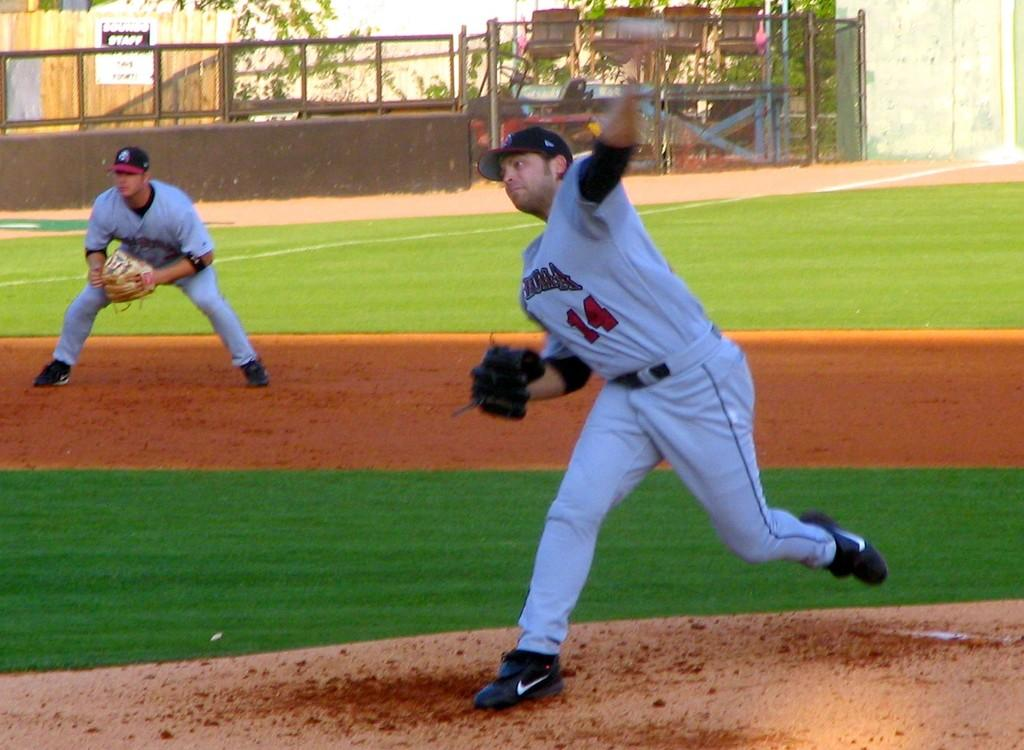<image>
Write a terse but informative summary of the picture. Player number 14 on the baseball team goes to pitch the ball. 